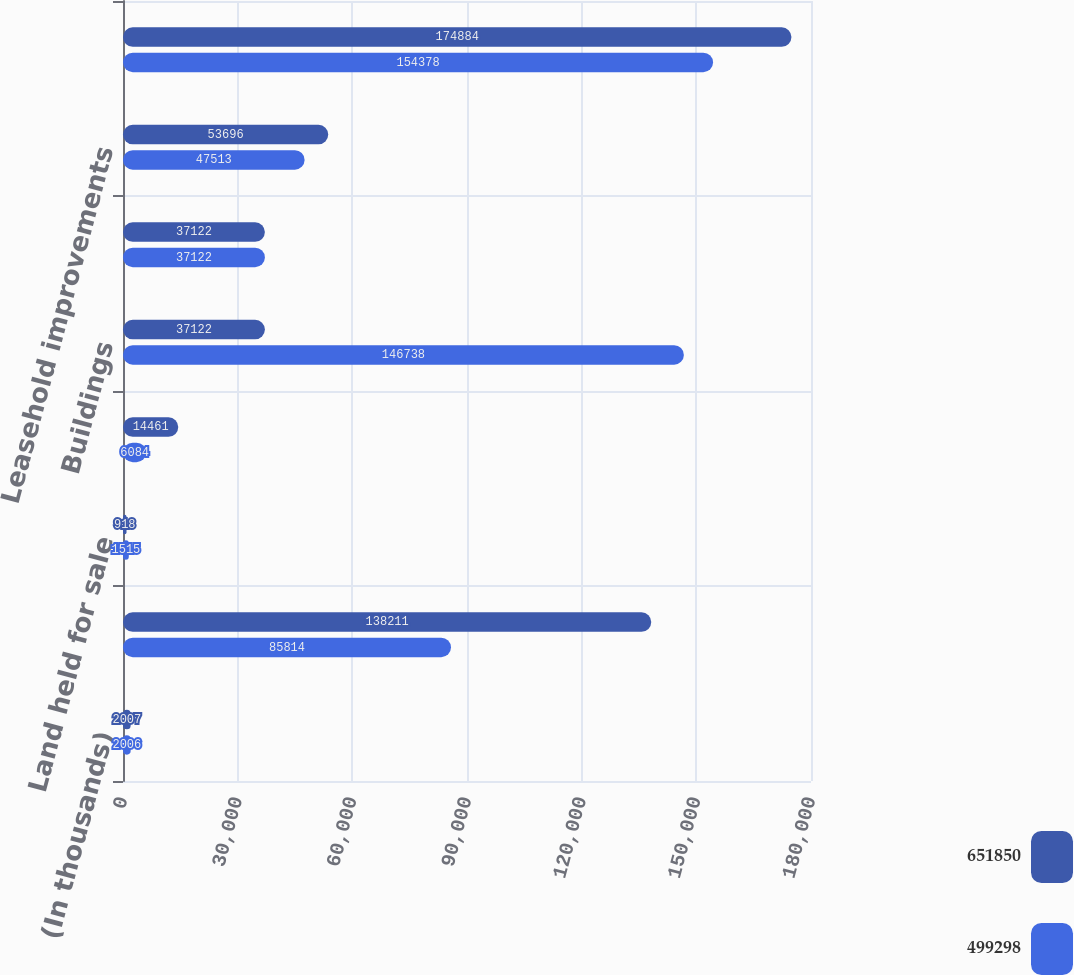Convert chart. <chart><loc_0><loc_0><loc_500><loc_500><stacked_bar_chart><ecel><fcel>(In thousands)<fcel>Land<fcel>Land held for sale<fcel>Land held for development<fcel>Buildings<fcel>Capital leases<fcel>Leasehold improvements<fcel>Furniture fixtures and<nl><fcel>651850<fcel>2007<fcel>138211<fcel>918<fcel>14461<fcel>37122<fcel>37122<fcel>53696<fcel>174884<nl><fcel>499298<fcel>2006<fcel>85814<fcel>1515<fcel>6084<fcel>146738<fcel>37122<fcel>47513<fcel>154378<nl></chart> 